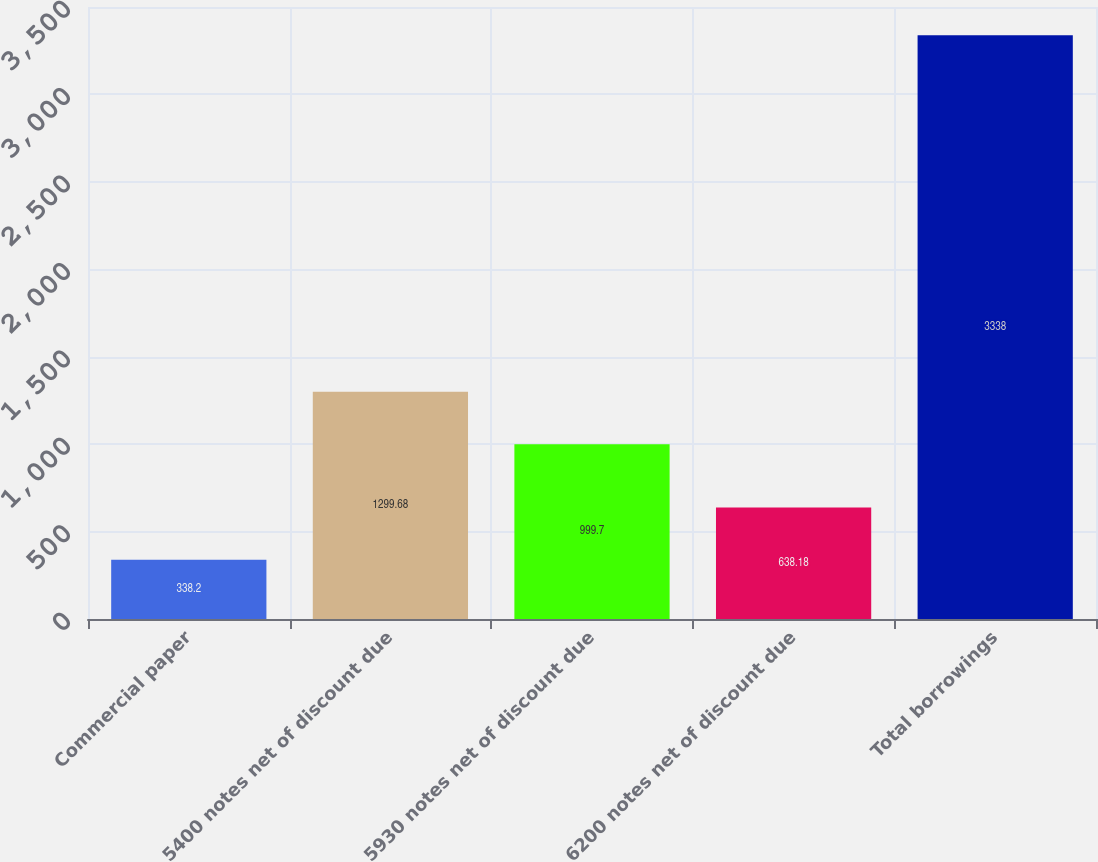Convert chart to OTSL. <chart><loc_0><loc_0><loc_500><loc_500><bar_chart><fcel>Commercial paper<fcel>5400 notes net of discount due<fcel>5930 notes net of discount due<fcel>6200 notes net of discount due<fcel>Total borrowings<nl><fcel>338.2<fcel>1299.68<fcel>999.7<fcel>638.18<fcel>3338<nl></chart> 